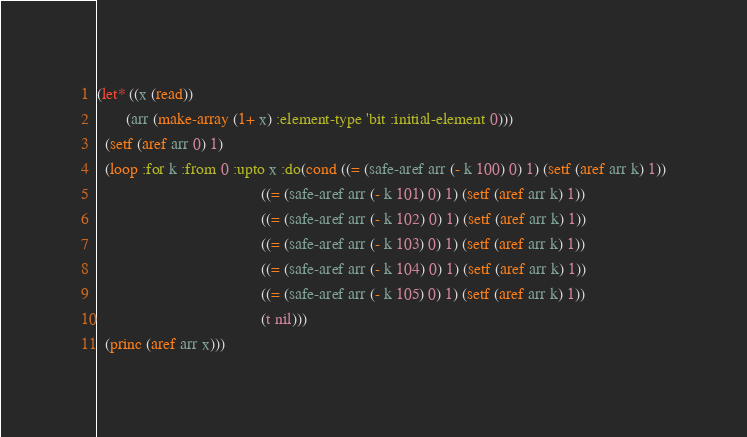Convert code to text. <code><loc_0><loc_0><loc_500><loc_500><_Lisp_>(let* ((x (read))
       (arr (make-array (1+ x) :element-type 'bit :initial-element 0)))
  (setf (aref arr 0) 1)
  (loop :for k :from 0 :upto x :do(cond ((= (safe-aref arr (- k 100) 0) 1) (setf (aref arr k) 1))
                                        ((= (safe-aref arr (- k 101) 0) 1) (setf (aref arr k) 1))
                                        ((= (safe-aref arr (- k 102) 0) 1) (setf (aref arr k) 1))
                                        ((= (safe-aref arr (- k 103) 0) 1) (setf (aref arr k) 1))
                                        ((= (safe-aref arr (- k 104) 0) 1) (setf (aref arr k) 1))
                                        ((= (safe-aref arr (- k 105) 0) 1) (setf (aref arr k) 1))
                                        (t nil)))
  (princ (aref arr x)))</code> 